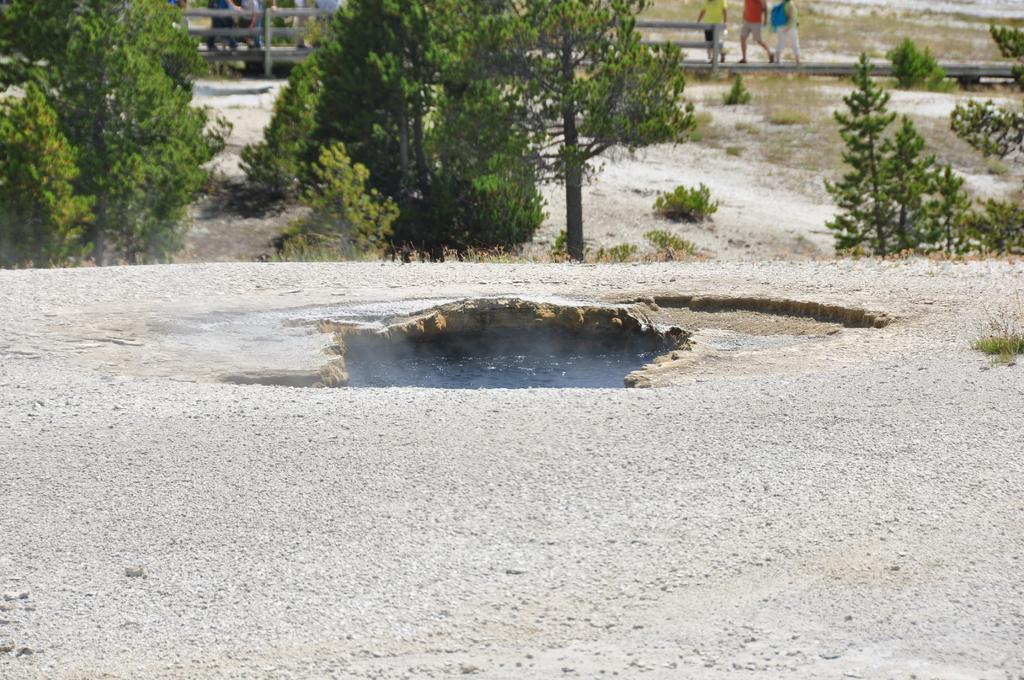What type of objects can be seen at the bottom of the image? There are stones in the image. What can be seen at the top of the image? There are trees at the top of the image. What is located behind the trees? There is a fencing behind the trees. What is happening behind the fencing? There are people walking behind the fencing. What type of stew is being served in the image? There is no stew present in the image. How do the people walking behind the fencing say good-bye to each other? There is no indication of people saying good-bye in the image. 